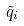Convert formula to latex. <formula><loc_0><loc_0><loc_500><loc_500>\tilde { q } _ { i }</formula> 